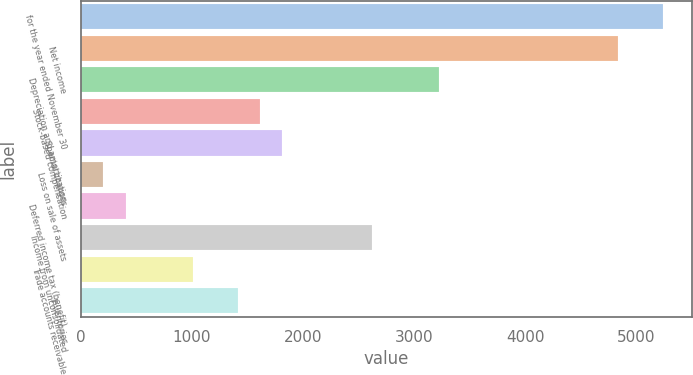Convert chart to OTSL. <chart><loc_0><loc_0><loc_500><loc_500><bar_chart><fcel>for the year ended November 30<fcel>Net income<fcel>Depreciation and amortization<fcel>Stock-based compensation<fcel>Special charges<fcel>Loss on sale of assets<fcel>Deferred income tax (benefit)<fcel>Income from unconsolidated<fcel>Trade accounts receivable<fcel>Inventories<nl><fcel>5238.36<fcel>4835.44<fcel>3223.76<fcel>1612.08<fcel>1813.54<fcel>201.86<fcel>403.32<fcel>2619.38<fcel>1007.7<fcel>1410.62<nl></chart> 